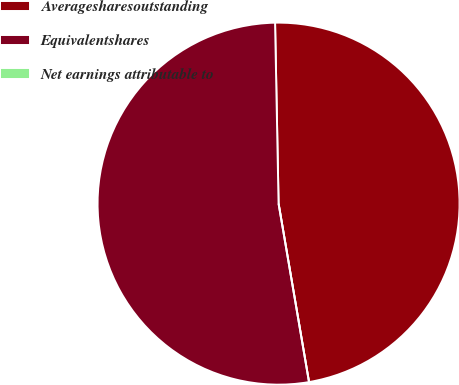<chart> <loc_0><loc_0><loc_500><loc_500><pie_chart><fcel>Averagesharesoutstanding<fcel>Equivalentshares<fcel>Net earnings attributable to<nl><fcel>47.62%<fcel>52.38%<fcel>0.0%<nl></chart> 